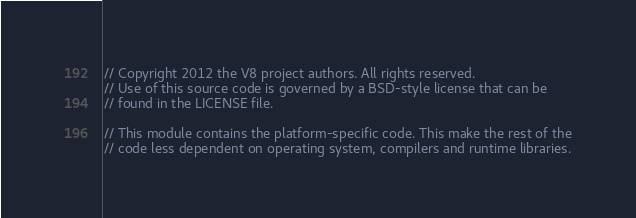<code> <loc_0><loc_0><loc_500><loc_500><_C_>// Copyright 2012 the V8 project authors. All rights reserved.
// Use of this source code is governed by a BSD-style license that can be
// found in the LICENSE file.

// This module contains the platform-specific code. This make the rest of the
// code less dependent on operating system, compilers and runtime libraries.</code> 